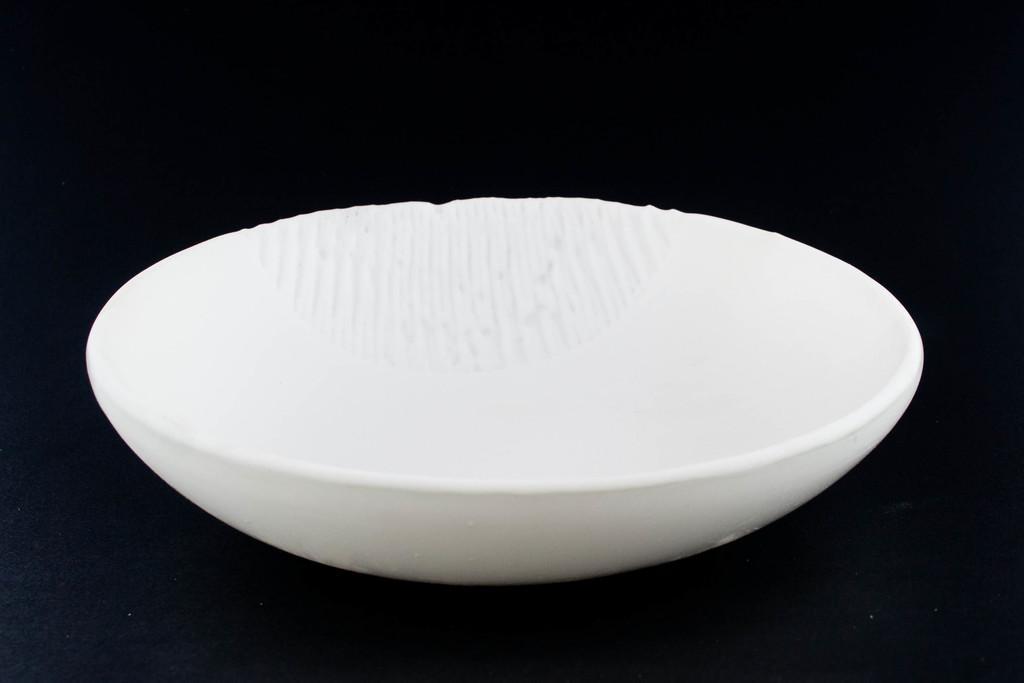In one or two sentences, can you explain what this image depicts? In the center of the image, we can see a bowl, which is in white color and the background is dark. 